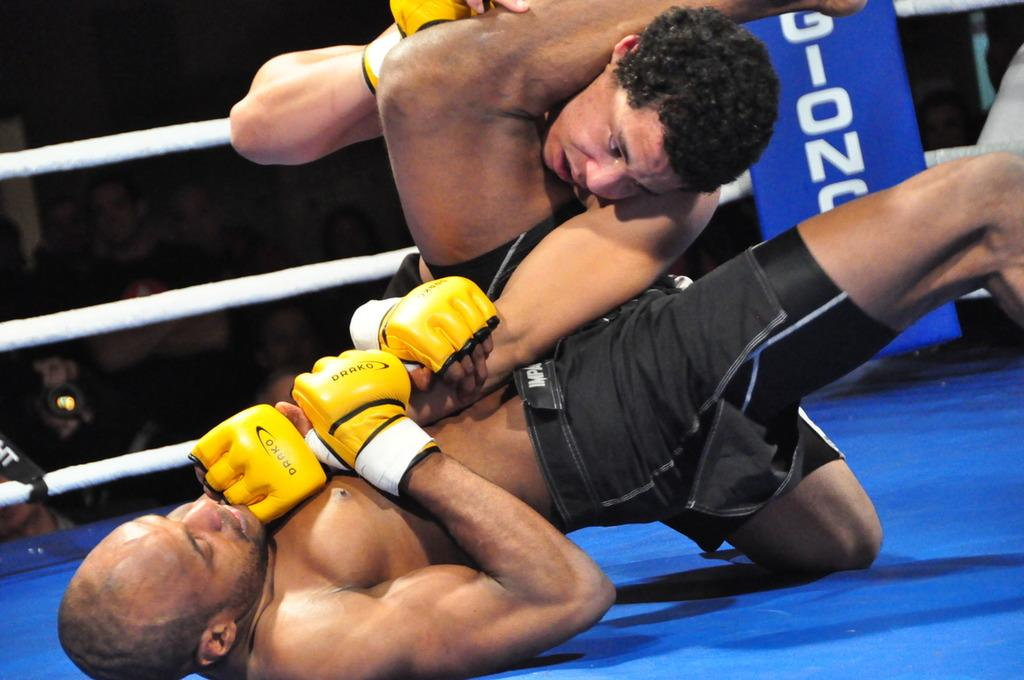Provide a one-sentence caption for the provided image. Two men are wrestling in a rink and wearing gloves with the word drako on them. 